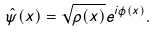Convert formula to latex. <formula><loc_0><loc_0><loc_500><loc_500>\hat { \psi } ( x ) = \sqrt { \rho ( x ) } e ^ { i \phi ( x ) } .</formula> 